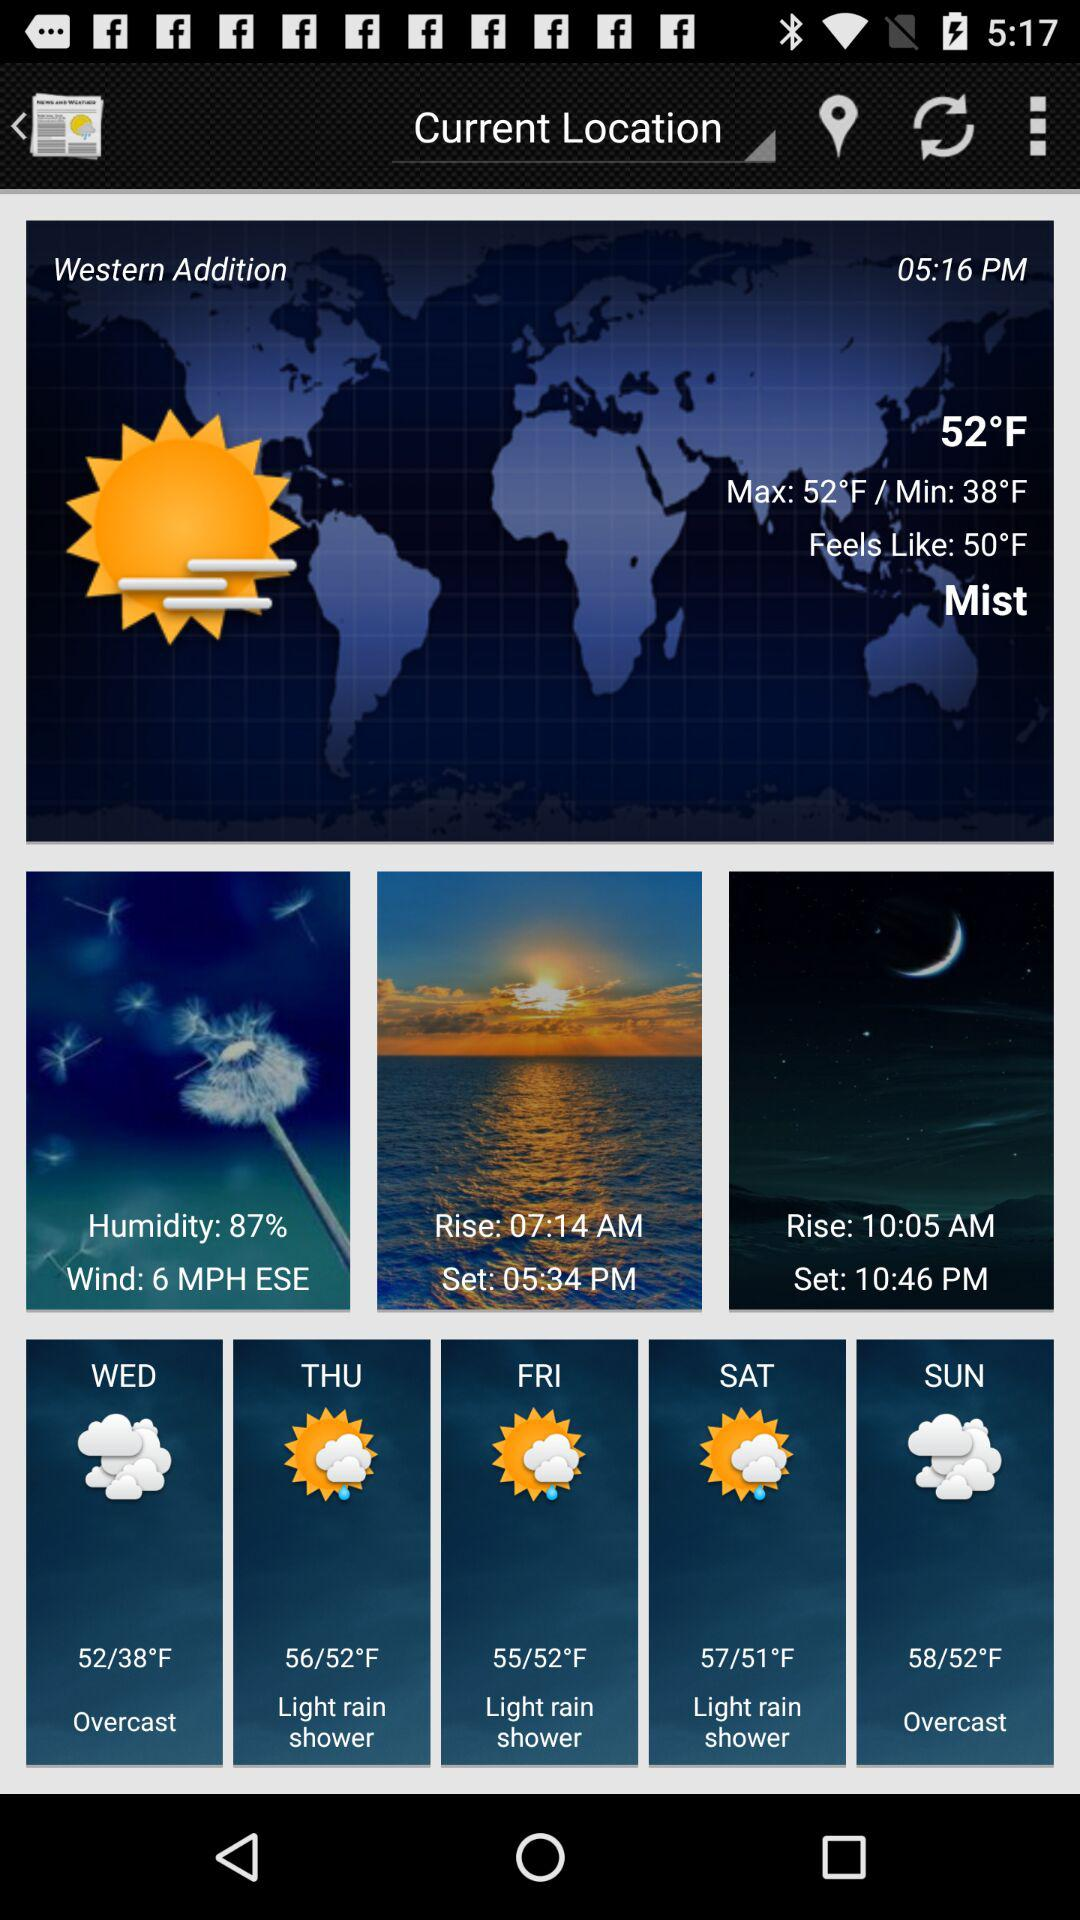What is the time of sunset? The time of sunset is 5:34 p.m. 